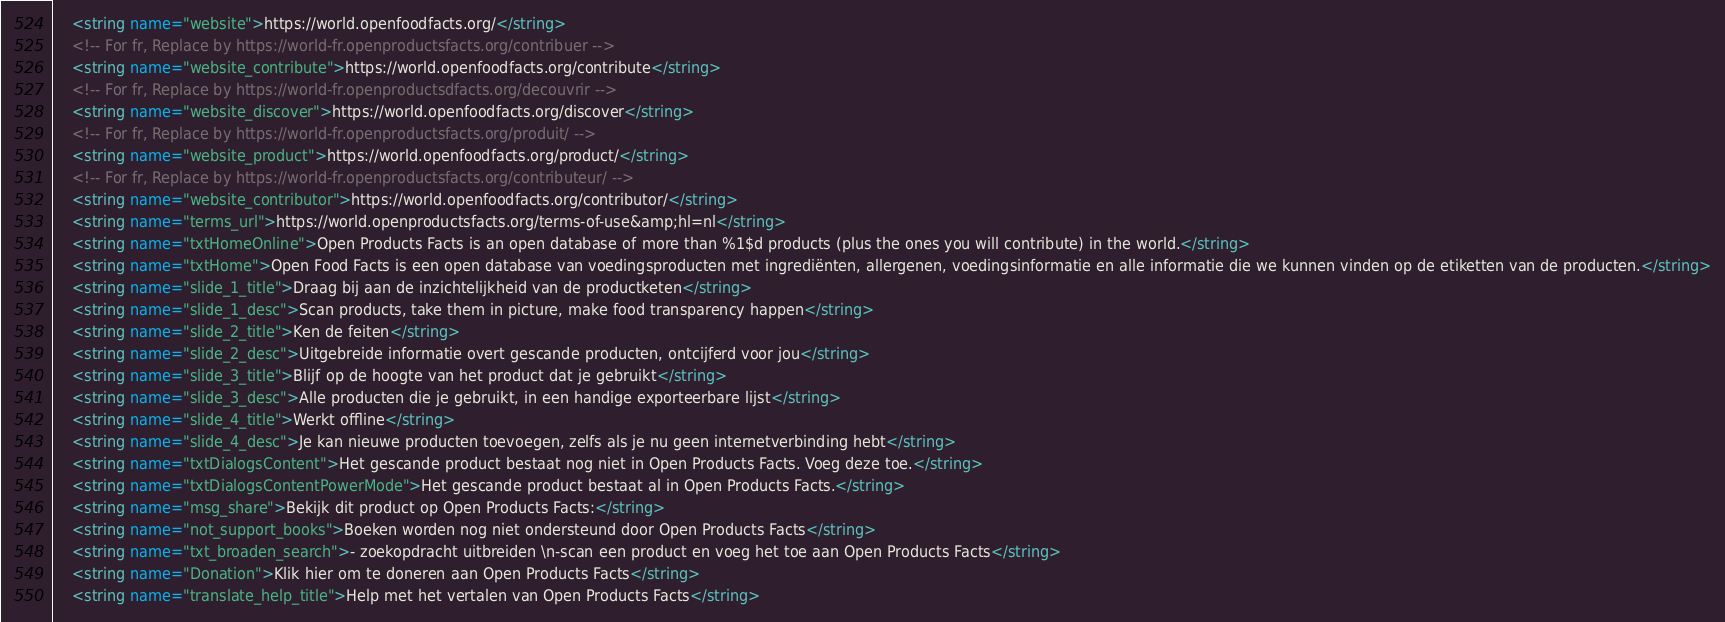<code> <loc_0><loc_0><loc_500><loc_500><_XML_>    <string name="website">https://world.openfoodfacts.org/</string>
    <!-- For fr, Replace by https://world-fr.openproductsfacts.org/contribuer -->
    <string name="website_contribute">https://world.openfoodfacts.org/contribute</string>
    <!-- For fr, Replace by https://world-fr.openproductsdfacts.org/decouvrir -->
    <string name="website_discover">https://world.openfoodfacts.org/discover</string>
    <!-- For fr, Replace by https://world-fr.openproductsfacts.org/produit/ -->
    <string name="website_product">https://world.openfoodfacts.org/product/</string>
    <!-- For fr, Replace by https://world-fr.openproductsfacts.org/contributeur/ -->
    <string name="website_contributor">https://world.openfoodfacts.org/contributor/</string>
    <string name="terms_url">https://world.openproductsfacts.org/terms-of-use&amp;hl=nl</string>
    <string name="txtHomeOnline">Open Products Facts is an open database of more than %1$d products (plus the ones you will contribute) in the world.</string>
    <string name="txtHome">Open Food Facts is een open database van voedingsproducten met ingrediënten, allergenen, voedingsinformatie en alle informatie die we kunnen vinden op de etiketten van de producten.</string>
    <string name="slide_1_title">Draag bij aan de inzichtelijkheid van de productketen</string>
    <string name="slide_1_desc">Scan products, take them in picture, make food transparency happen</string>
    <string name="slide_2_title">Ken de feiten</string>
    <string name="slide_2_desc">Uitgebreide informatie overt gescande producten, ontcijferd voor jou</string>
    <string name="slide_3_title">Blijf op de hoogte van het product dat je gebruikt</string>
    <string name="slide_3_desc">Alle producten die je gebruikt, in een handige exporteerbare lijst</string>
    <string name="slide_4_title">Werkt offline</string>
    <string name="slide_4_desc">Je kan nieuwe producten toevoegen, zelfs als je nu geen internetverbinding hebt</string>
    <string name="txtDialogsContent">Het gescande product bestaat nog niet in Open Products Facts. Voeg deze toe.</string>
    <string name="txtDialogsContentPowerMode">Het gescande product bestaat al in Open Products Facts.</string>
    <string name="msg_share">Bekijk dit product op Open Products Facts:</string>
    <string name="not_support_books">Boeken worden nog niet ondersteund door Open Products Facts</string>
    <string name="txt_broaden_search">- zoekopdracht uitbreiden \n-scan een product en voeg het toe aan Open Products Facts</string>
    <string name="Donation">Klik hier om te doneren aan Open Products Facts</string>
    <string name="translate_help_title">Help met het vertalen van Open Products Facts</string></code> 